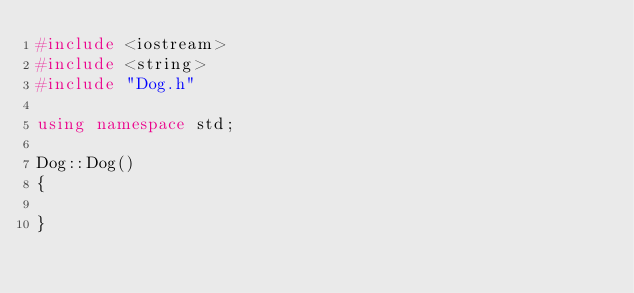<code> <loc_0><loc_0><loc_500><loc_500><_C++_>#include <iostream>
#include <string>
#include "Dog.h"

using namespace std;

Dog::Dog()
{
    
}

</code> 